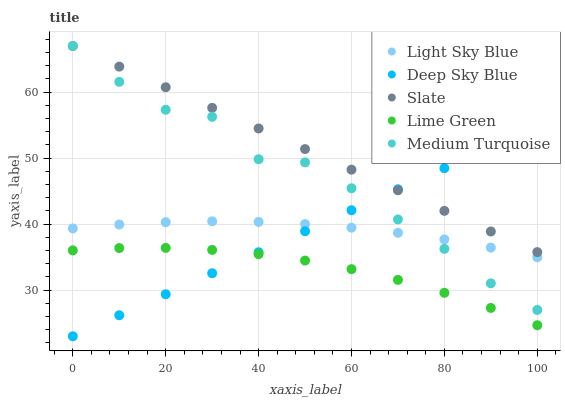Does Lime Green have the minimum area under the curve?
Answer yes or no. Yes. Does Slate have the maximum area under the curve?
Answer yes or no. Yes. Does Light Sky Blue have the minimum area under the curve?
Answer yes or no. No. Does Light Sky Blue have the maximum area under the curve?
Answer yes or no. No. Is Slate the smoothest?
Answer yes or no. Yes. Is Medium Turquoise the roughest?
Answer yes or no. Yes. Is Light Sky Blue the smoothest?
Answer yes or no. No. Is Light Sky Blue the roughest?
Answer yes or no. No. Does Deep Sky Blue have the lowest value?
Answer yes or no. Yes. Does Light Sky Blue have the lowest value?
Answer yes or no. No. Does Medium Turquoise have the highest value?
Answer yes or no. Yes. Does Light Sky Blue have the highest value?
Answer yes or no. No. Is Lime Green less than Slate?
Answer yes or no. Yes. Is Medium Turquoise greater than Lime Green?
Answer yes or no. Yes. Does Medium Turquoise intersect Deep Sky Blue?
Answer yes or no. Yes. Is Medium Turquoise less than Deep Sky Blue?
Answer yes or no. No. Is Medium Turquoise greater than Deep Sky Blue?
Answer yes or no. No. Does Lime Green intersect Slate?
Answer yes or no. No. 